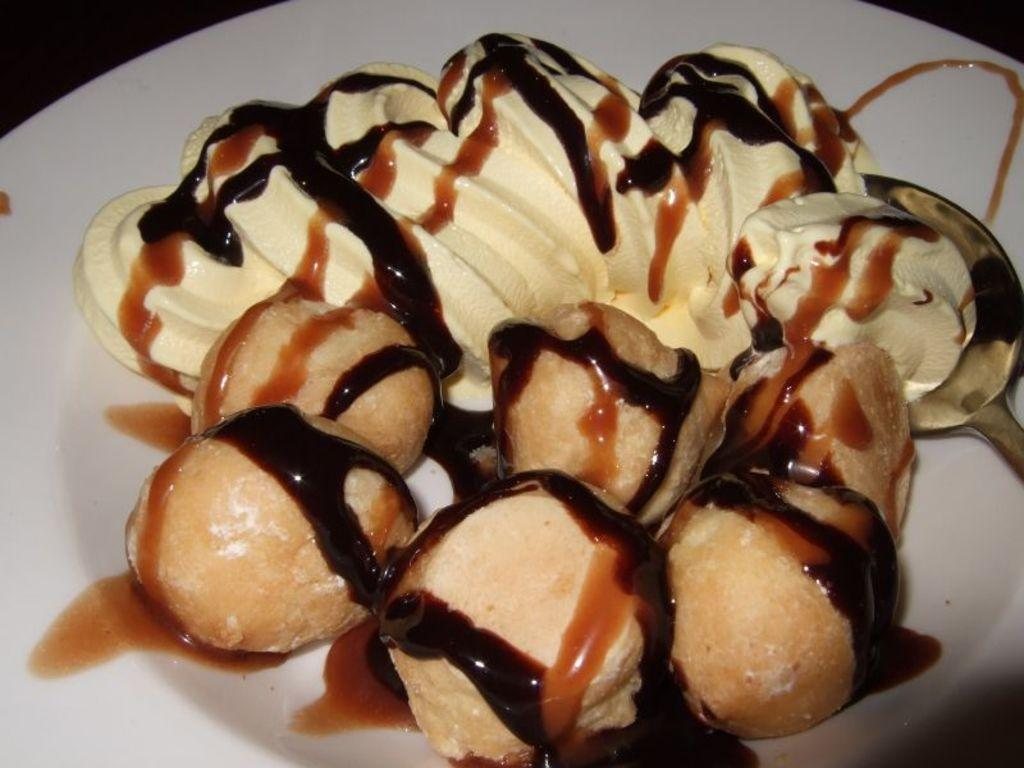What types of objects are present in the image? There are food items and a spoon on a plate in the image. Can you describe the spoon in the image? The spoon is on a plate in the image. What might be used to eat the food items in the image? The spoon on the plate could be used to eat the food items. How many chairs are visible in the image? There are no chairs present in the image. Is there any popcorn visible in the image? There is no popcorn present in the image. 